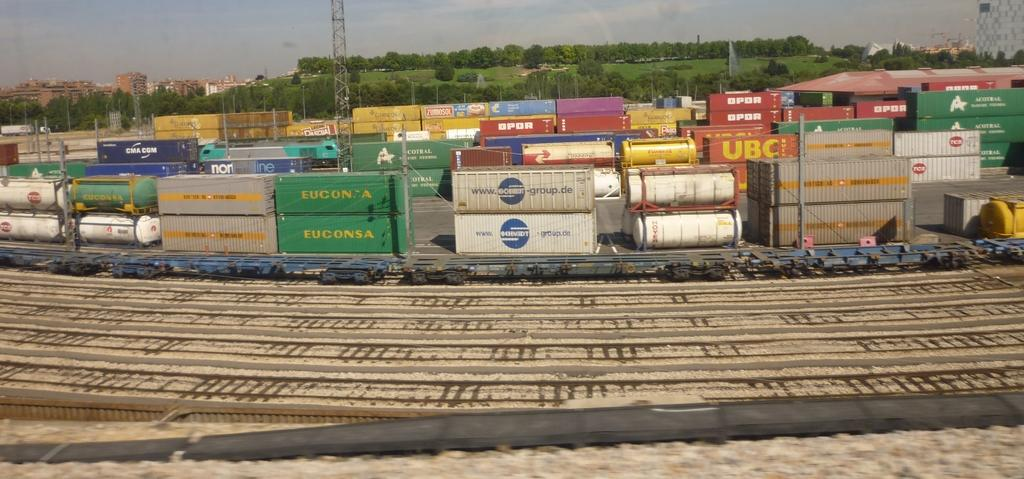<image>
Present a compact description of the photo's key features. Group of containers together with a green one that says EUCONSA. 